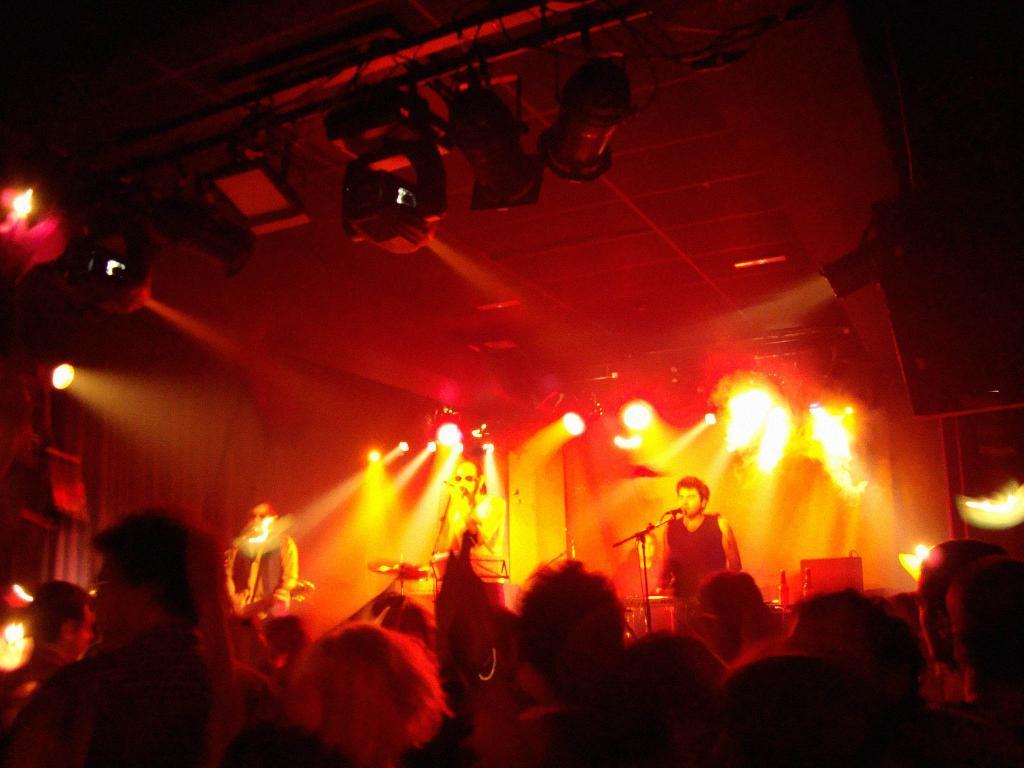Can you describe this image briefly? In this image at the bottom, there are many people. In the middle there is a man, he is singing. On the right there is a man, he wears a t shirt, in front of him there is a mic. On the left there is a man, he is playing a guitar. In the background there are lights, musical instruments. 